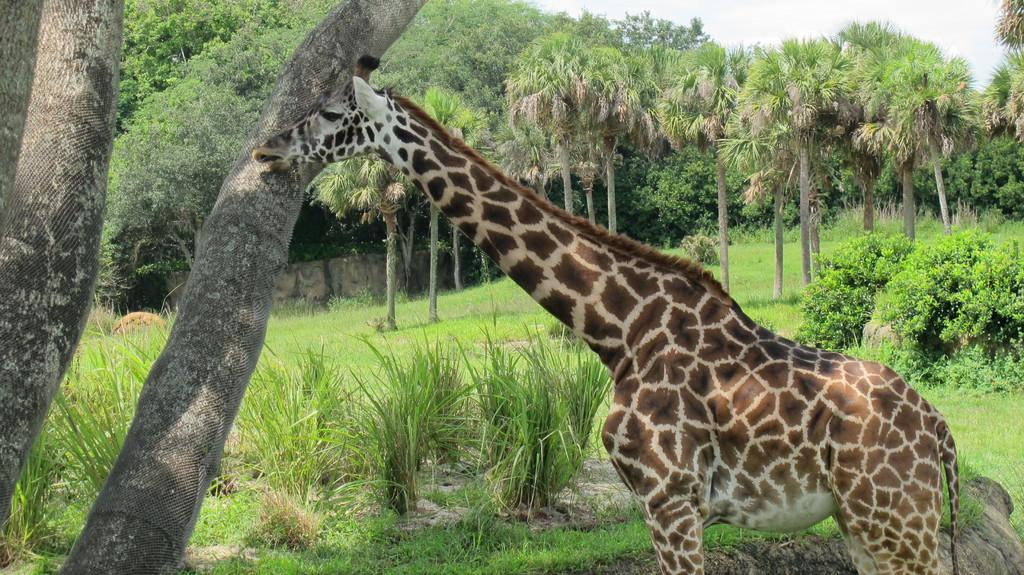What animal is the main subject of the image? There is a giraffe in the image. What type of vegetation is visible behind the giraffe? There are plants, grass, and trees behind the giraffe. What is the background of the image? The background includes a wall and the sky, which is visible behind the trees. What type of orange can be seen growing on the ground in the image? There is no orange or any indication of an orange tree present in the image. 